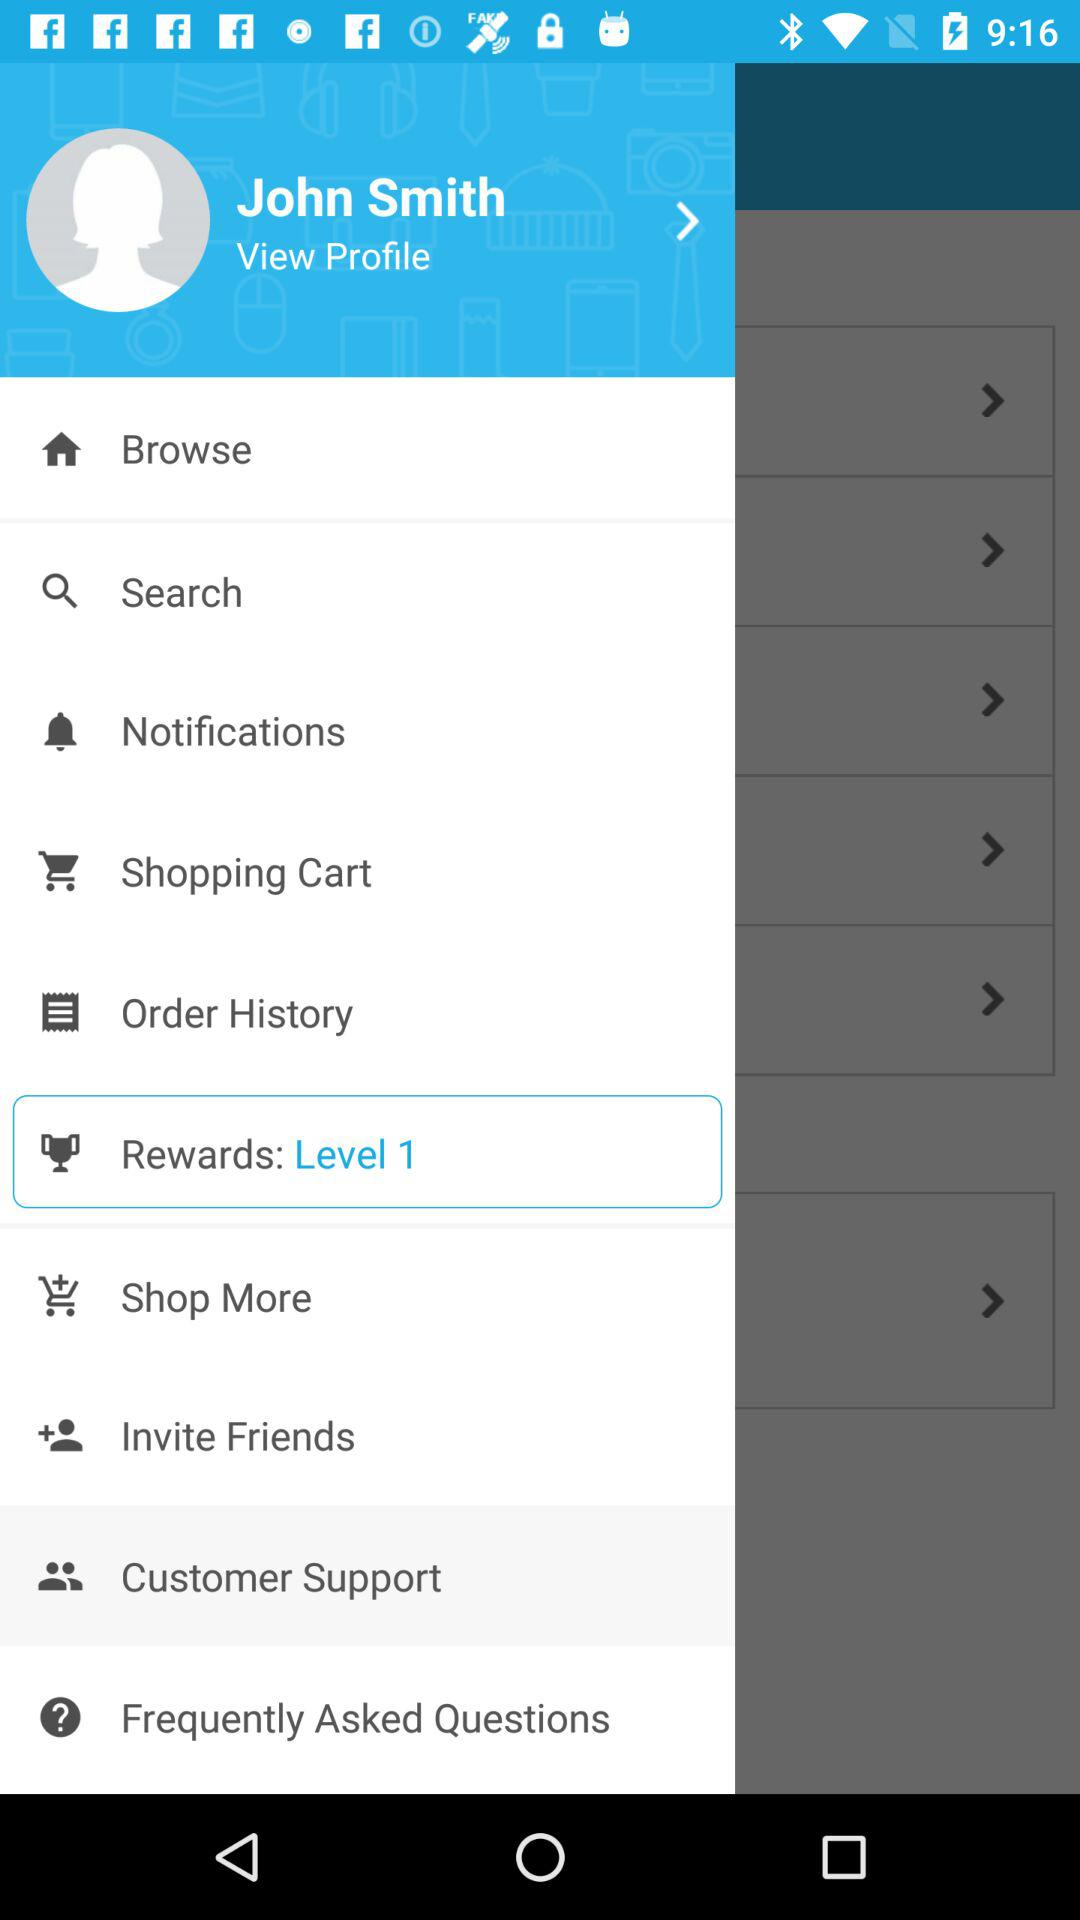At what level are we right now? We are at level 1. 